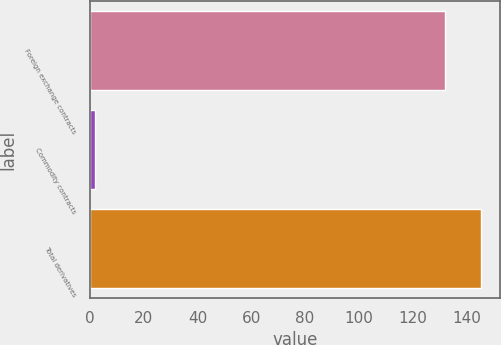<chart> <loc_0><loc_0><loc_500><loc_500><bar_chart><fcel>Foreign exchange contracts<fcel>Commodity contracts<fcel>Total derivatives<nl><fcel>132<fcel>2<fcel>145.4<nl></chart> 